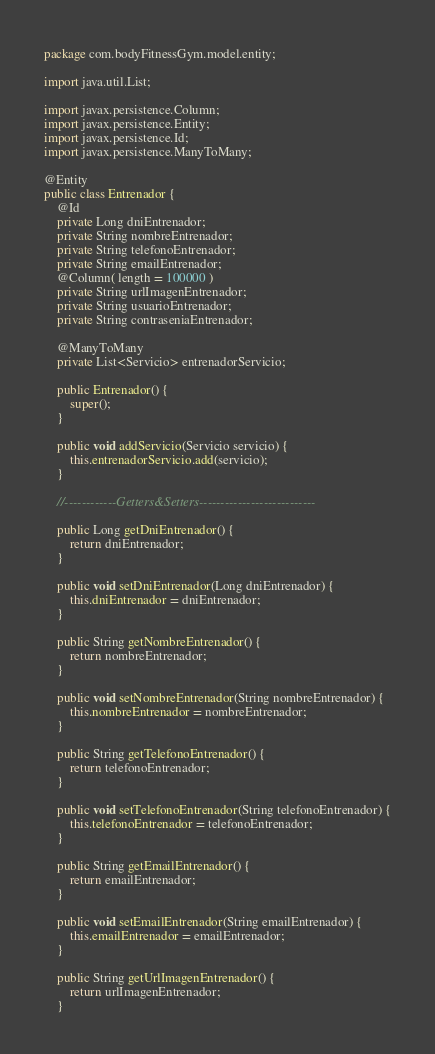<code> <loc_0><loc_0><loc_500><loc_500><_Java_>package com.bodyFitnessGym.model.entity;

import java.util.List;

import javax.persistence.Column;
import javax.persistence.Entity;
import javax.persistence.Id;
import javax.persistence.ManyToMany;

@Entity
public class Entrenador {
	@Id
	private Long dniEntrenador;
	private String nombreEntrenador;
	private String telefonoEntrenador;
	private String emailEntrenador;
	@Column( length = 100000 )
	private String urlImagenEntrenador;
	private String usuarioEntrenador;
	private String contraseniaEntrenador;

	@ManyToMany
	private List<Servicio> entrenadorServicio;

	public Entrenador() {
		super();
	}
	
	public void addServicio(Servicio servicio) {
		this.entrenadorServicio.add(servicio);
	}

	//------------Getters&Setters---------------------------
	
	public Long getDniEntrenador() {
		return dniEntrenador;
	}

	public void setDniEntrenador(Long dniEntrenador) {
		this.dniEntrenador = dniEntrenador;
	}

	public String getNombreEntrenador() {
		return nombreEntrenador;
	}

	public void setNombreEntrenador(String nombreEntrenador) {
		this.nombreEntrenador = nombreEntrenador;
	}

	public String getTelefonoEntrenador() {
		return telefonoEntrenador;
	}

	public void setTelefonoEntrenador(String telefonoEntrenador) {
		this.telefonoEntrenador = telefonoEntrenador;
	}

	public String getEmailEntrenador() {
		return emailEntrenador;
	}

	public void setEmailEntrenador(String emailEntrenador) {
		this.emailEntrenador = emailEntrenador;
	}

	public String getUrlImagenEntrenador() {
		return urlImagenEntrenador;
	}
</code> 